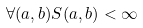<formula> <loc_0><loc_0><loc_500><loc_500>\forall ( a , b ) S ( a , b ) < \infty</formula> 